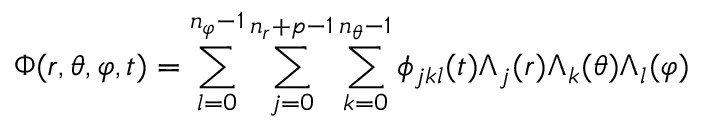<formula> <loc_0><loc_0><loc_500><loc_500>\Phi ( r , \theta , \varphi , t ) = \sum _ { l = 0 } ^ { n _ { \varphi } - 1 } \sum _ { j = 0 } ^ { n _ { r } + p - 1 } \sum _ { k = 0 } ^ { n _ { \theta } - 1 } \phi _ { j k l } ( t ) \Lambda _ { j } ( r ) \Lambda _ { k } ( \theta ) \Lambda _ { l } ( \varphi )</formula> 